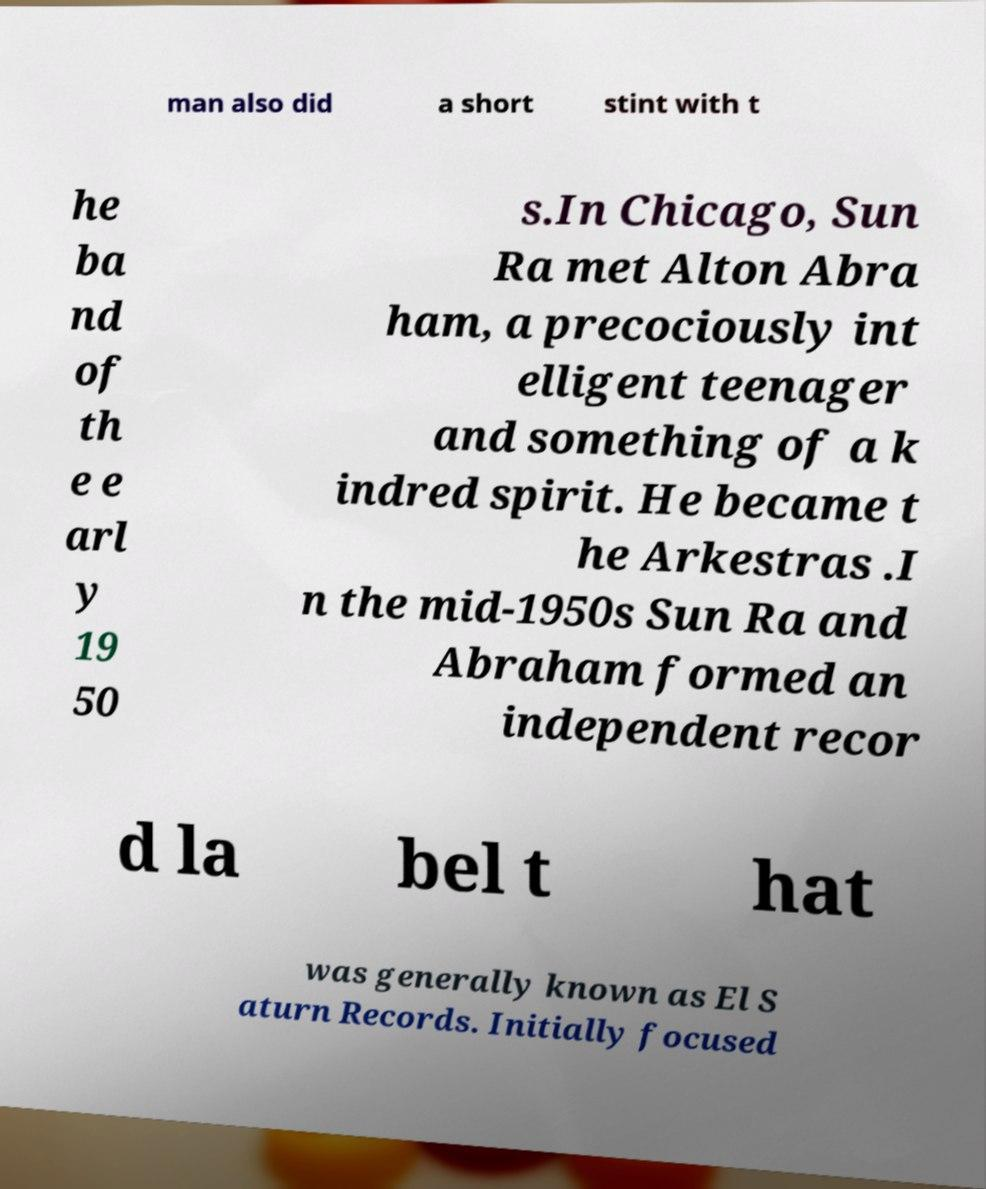Please identify and transcribe the text found in this image. man also did a short stint with t he ba nd of th e e arl y 19 50 s.In Chicago, Sun Ra met Alton Abra ham, a precociously int elligent teenager and something of a k indred spirit. He became t he Arkestras .I n the mid-1950s Sun Ra and Abraham formed an independent recor d la bel t hat was generally known as El S aturn Records. Initially focused 